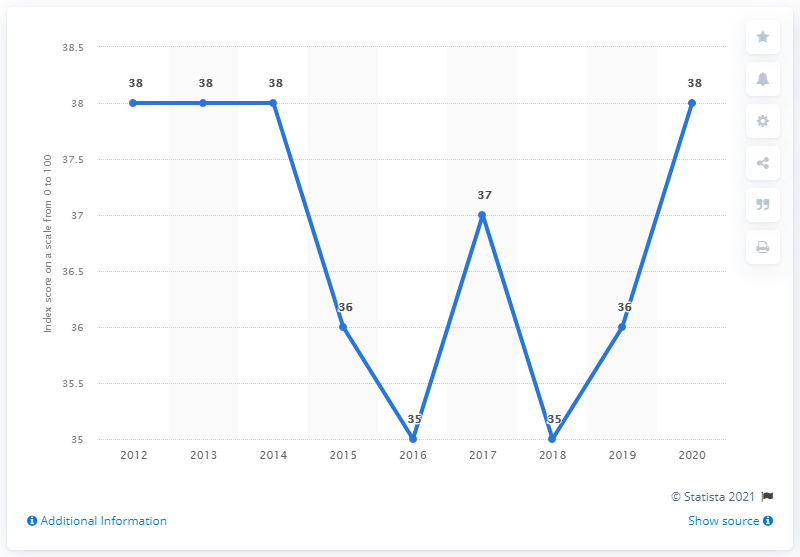Outline some significant characteristics in this image. During the period of 2012 to 2014, Peru's corruption perception index score was 38. The mode is a type of measure of central tendency that is used to identify the value that occurs most frequently in a data set. For example, if the data set is "38, 38, 40, 40, 40, 42," the mode would be "40," because it appears twice in the data set. It is estimated that approximately 2% of the population have the least number. 